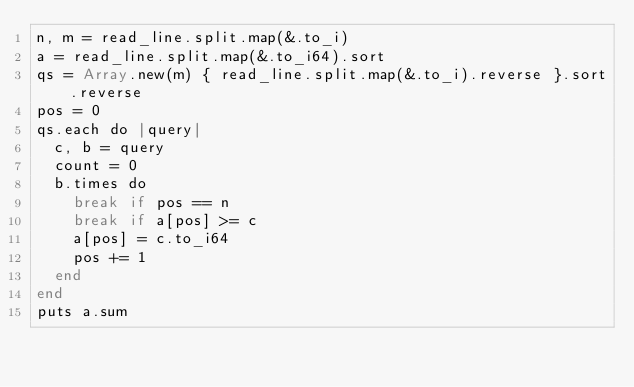<code> <loc_0><loc_0><loc_500><loc_500><_Crystal_>n, m = read_line.split.map(&.to_i)
a = read_line.split.map(&.to_i64).sort
qs = Array.new(m) { read_line.split.map(&.to_i).reverse }.sort.reverse
pos = 0
qs.each do |query|
  c, b = query
  count = 0
  b.times do
    break if pos == n
    break if a[pos] >= c
    a[pos] = c.to_i64
    pos += 1
  end
end
puts a.sum
</code> 